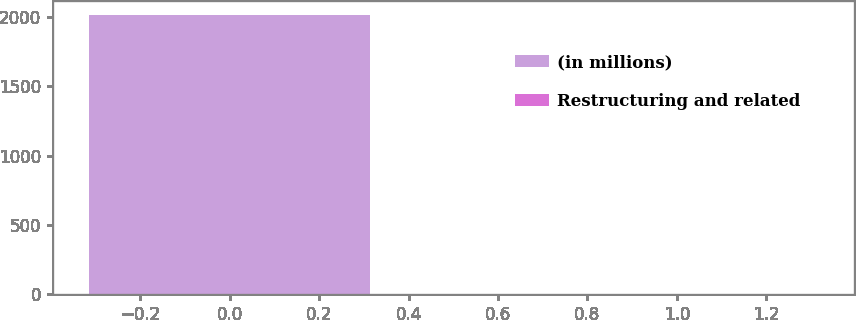<chart> <loc_0><loc_0><loc_500><loc_500><bar_chart><fcel>(in millions)<fcel>Restructuring and related<nl><fcel>2019<fcel>1.4<nl></chart> 